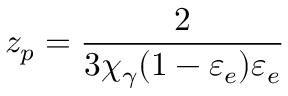Convert formula to latex. <formula><loc_0><loc_0><loc_500><loc_500>z _ { p } = \frac { 2 } { 3 \chi _ { \gamma } ( 1 - \varepsilon _ { e } ) \varepsilon _ { e } }</formula> 